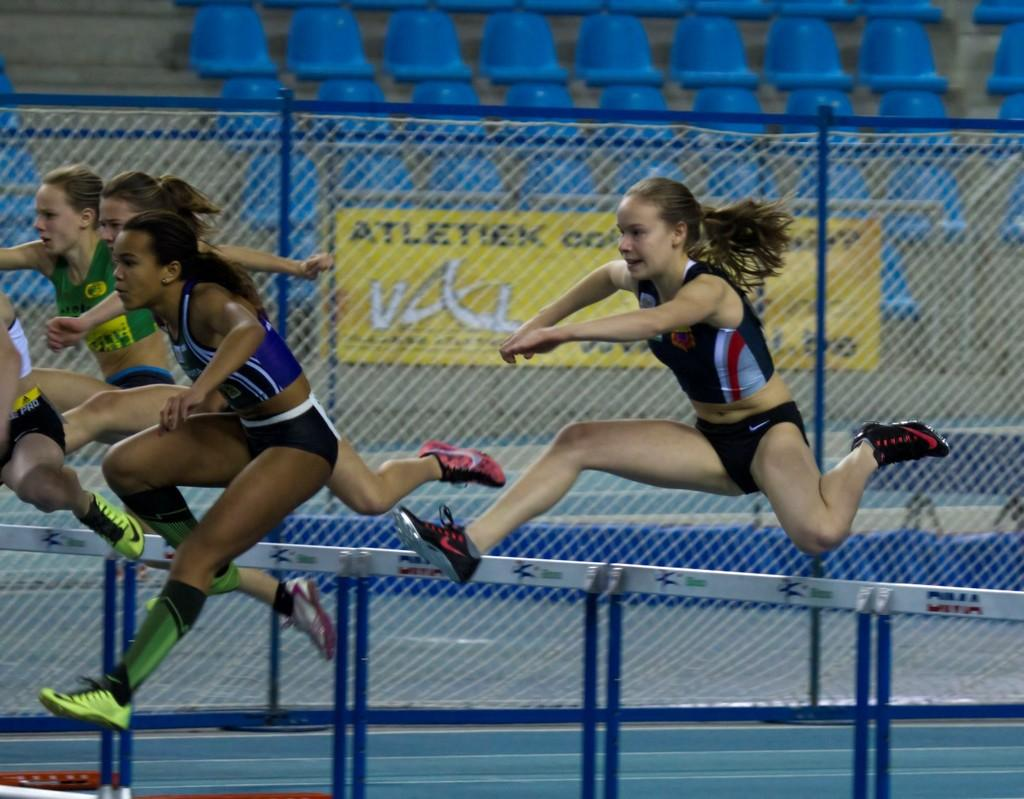Who or what is present in the image? There are people in the image. What can be seen in the background of the image? There is a mesh in the background of the image. What is written or displayed on the board in the image? There is a board with text in the image. What type of furniture is visible in the image? There are chairs in the image. What type of creature is sitting on the chair in the image? There is no creature present in the image; only people are visible. 